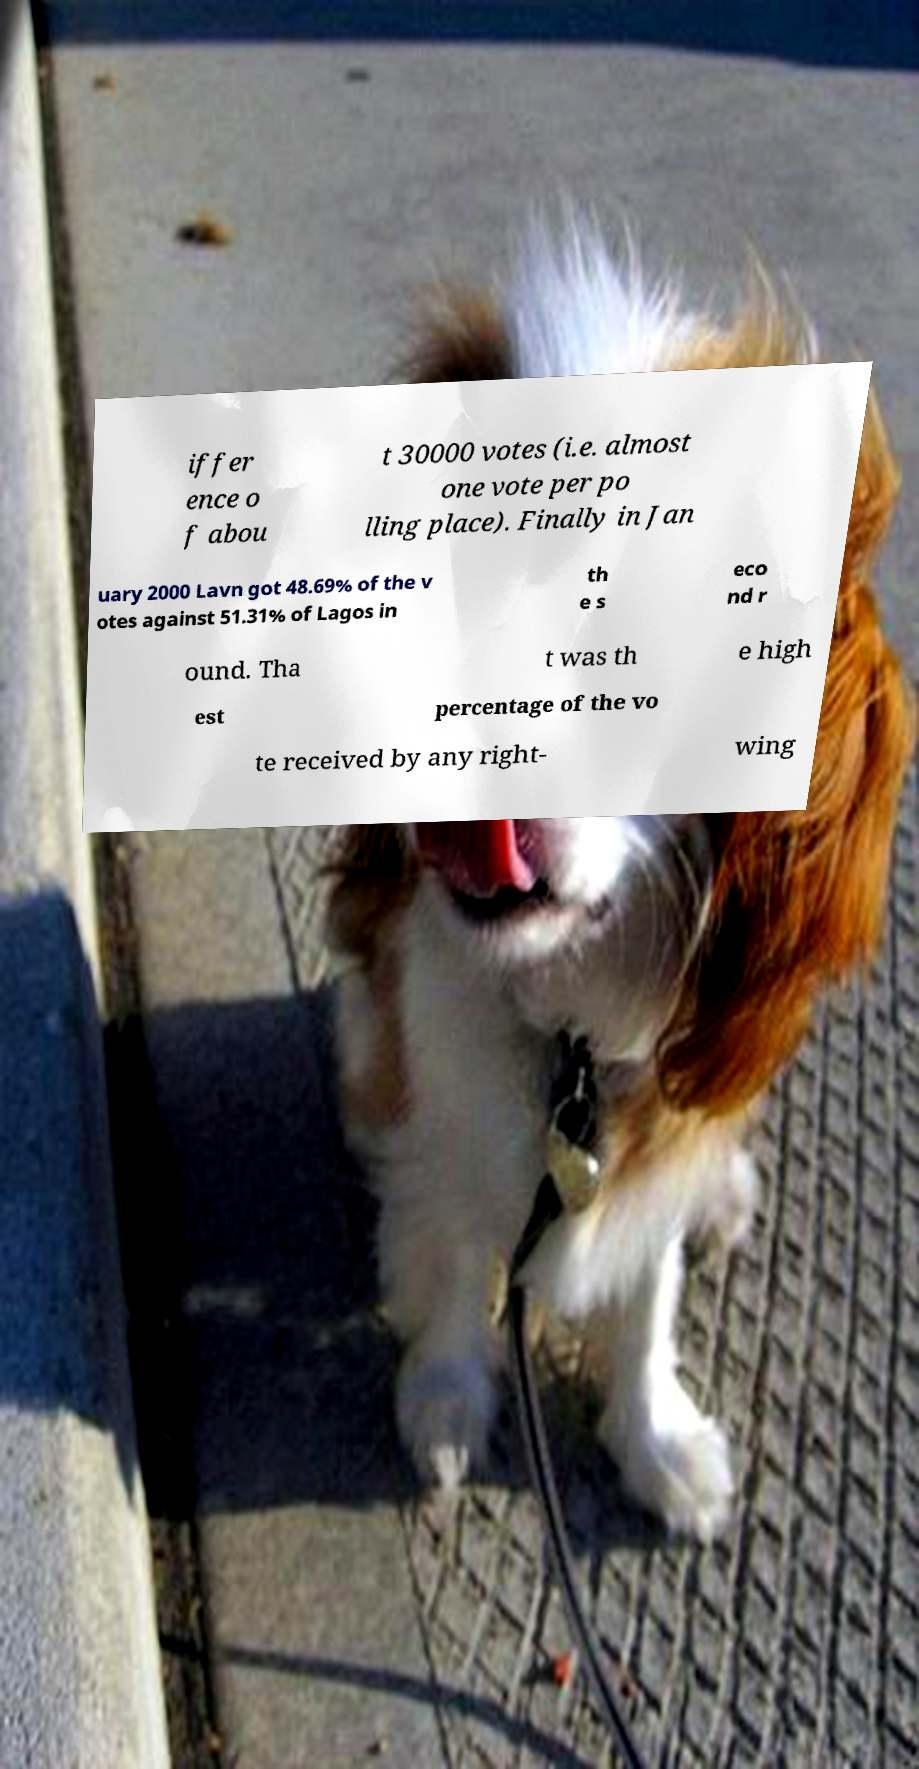What messages or text are displayed in this image? I need them in a readable, typed format. iffer ence o f abou t 30000 votes (i.e. almost one vote per po lling place). Finally in Jan uary 2000 Lavn got 48.69% of the v otes against 51.31% of Lagos in th e s eco nd r ound. Tha t was th e high est percentage of the vo te received by any right- wing 